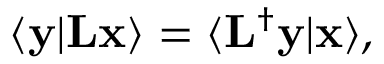Convert formula to latex. <formula><loc_0><loc_0><loc_500><loc_500>\langle y | L x \rangle = \langle L ^ { \dagger } y | x \rangle ,</formula> 